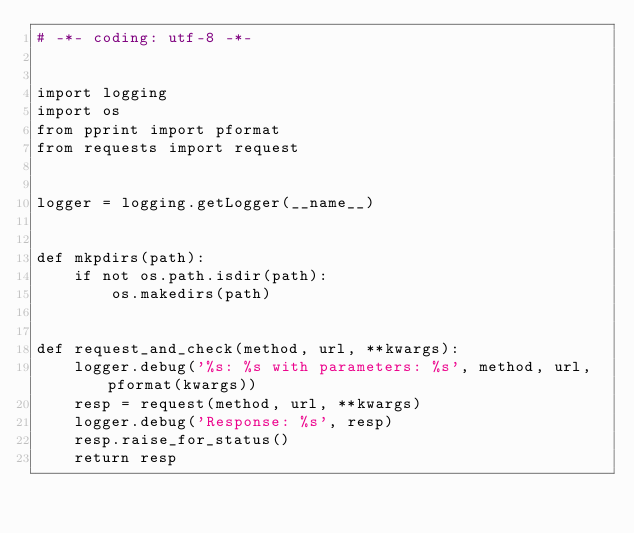Convert code to text. <code><loc_0><loc_0><loc_500><loc_500><_Python_># -*- coding: utf-8 -*-


import logging
import os
from pprint import pformat
from requests import request


logger = logging.getLogger(__name__)


def mkpdirs(path):
    if not os.path.isdir(path):
        os.makedirs(path)


def request_and_check(method, url, **kwargs):
    logger.debug('%s: %s with parameters: %s', method, url, pformat(kwargs))
    resp = request(method, url, **kwargs)
    logger.debug('Response: %s', resp)
    resp.raise_for_status()
    return resp
</code> 